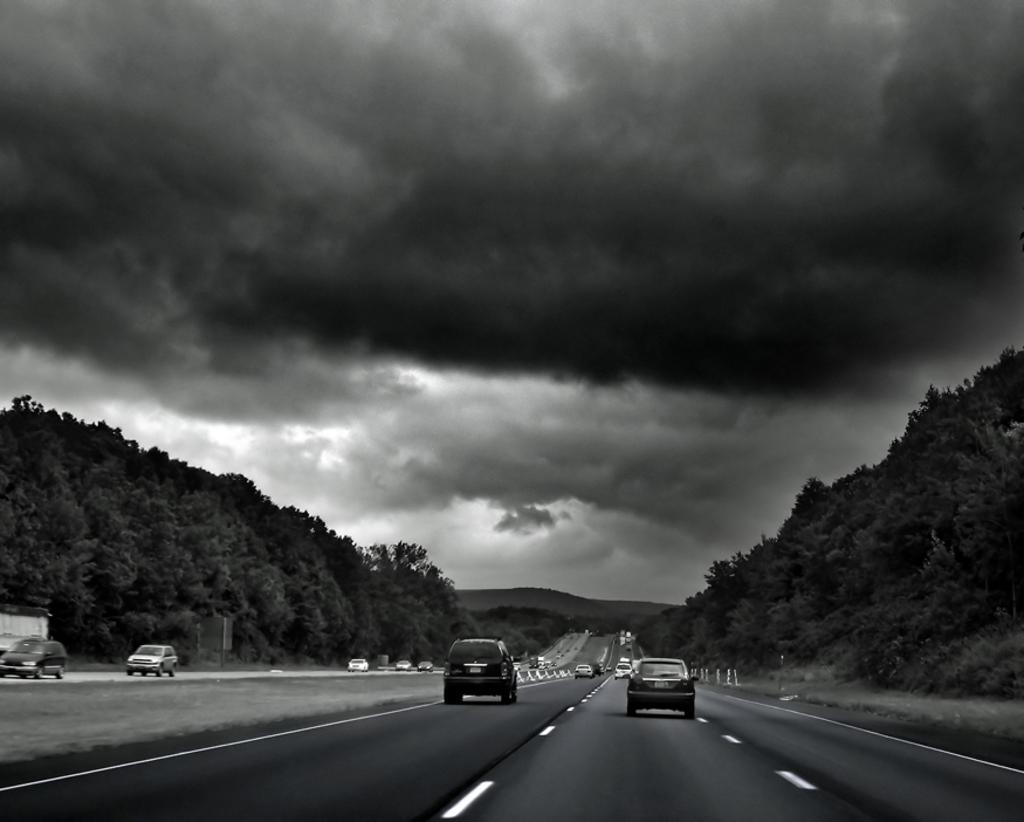What is the color scheme of the image? The image is black and white. What can be seen moving on the road in the image? There are vehicles moving on the road in the image. What type of vegetation is present on both sides of the image? There are trees on the right side and the left side of the image. What is visible in the background of the image? There are mountains and the sky visible in the background of the image. Where is the nest of the bird located in the image? There is no nest or bird present in the image. What type of card is being held by the person in the image? There is no person or card present in the image. 